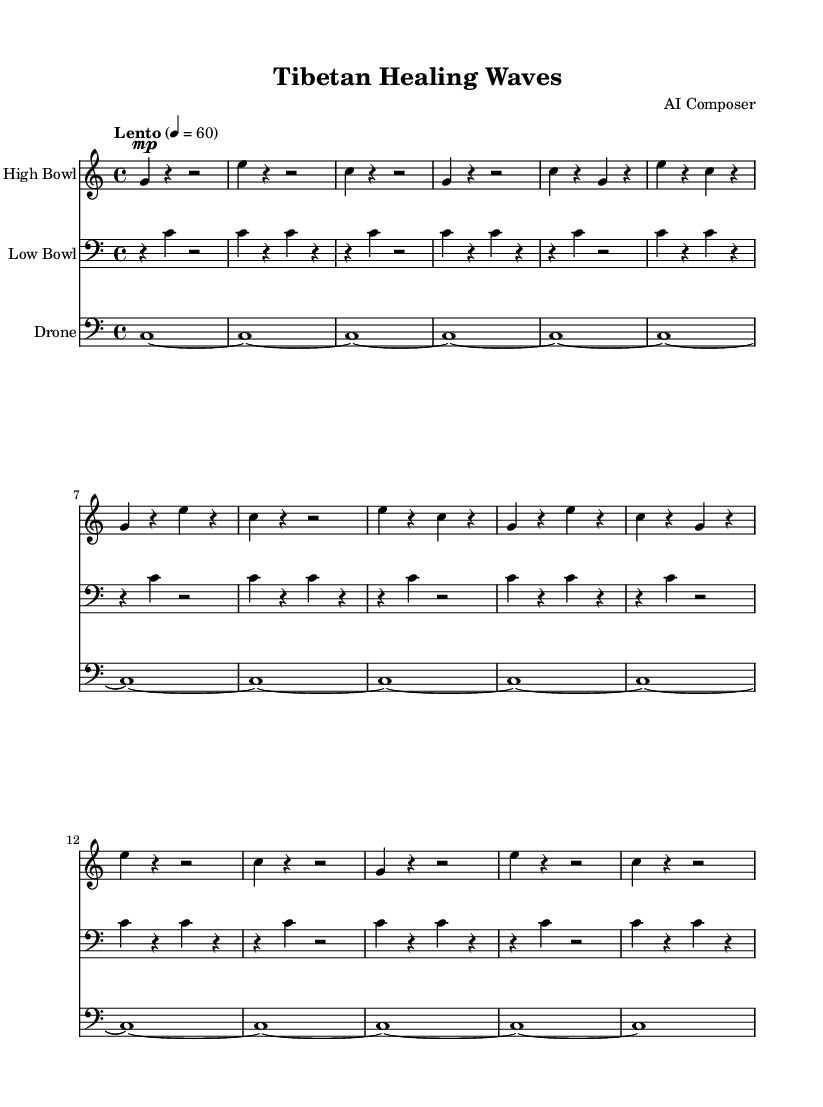What is the key signature of this music? The key signature is C major, which has no sharps or flats.
Answer: C major What is the time signature of this music? The time signature is indicated by the fraction at the beginning of the score, which is four beats per measure.
Answer: 4/4 What is the tempo marking of this piece? The tempo marking in the score is indicated as "Lento," which denotes a slow tempo.
Answer: Lento How many measures are there in the high bowl part? By counting the bars in the high bowl part, there are a total of 14 measures.
Answer: 14 Which instrument plays the lowest notes in the score? The low bowl part is notated in the bass clef, indicating it plays the lowest notes.
Answer: Low Bowl What kind of harmonic texture does this music feature? This piece features a drone in the bass, creating a harmonic foundation alongside the melodic bowls.
Answer: Drone How many times does the high bowl play the note G in the first section? Counting the instances of G in the high bowl part in the first section reveals it occurs 5 times.
Answer: 5 